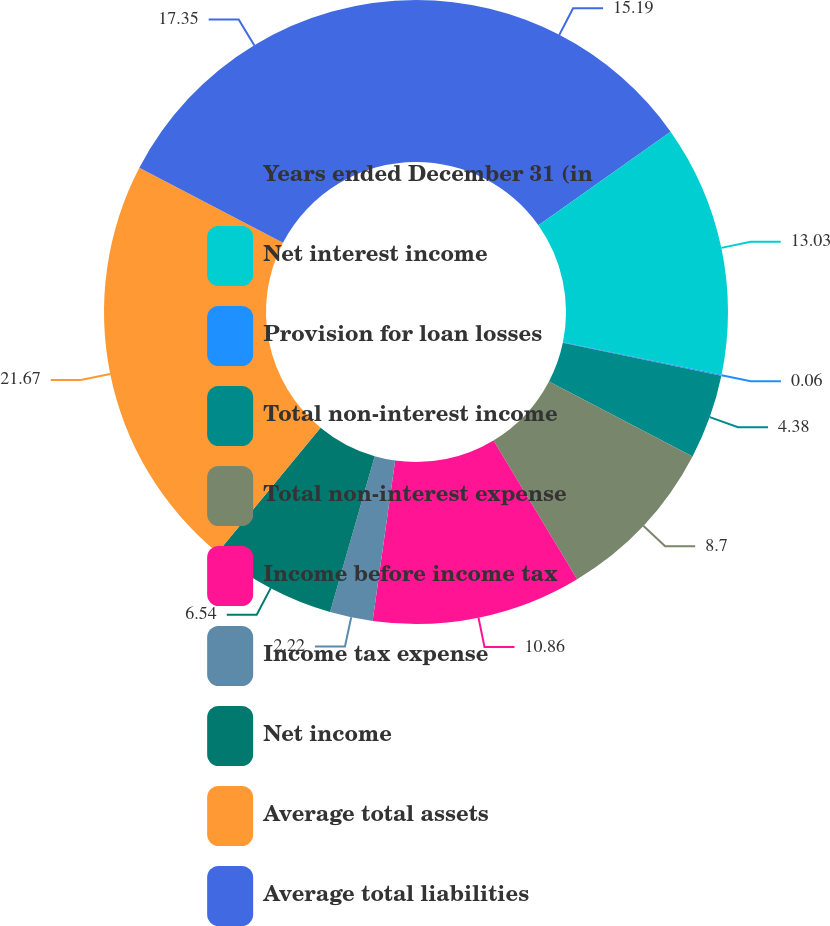Convert chart. <chart><loc_0><loc_0><loc_500><loc_500><pie_chart><fcel>Years ended December 31 (in<fcel>Net interest income<fcel>Provision for loan losses<fcel>Total non-interest income<fcel>Total non-interest expense<fcel>Income before income tax<fcel>Income tax expense<fcel>Net income<fcel>Average total assets<fcel>Average total liabilities<nl><fcel>15.19%<fcel>13.03%<fcel>0.06%<fcel>4.38%<fcel>8.7%<fcel>10.86%<fcel>2.22%<fcel>6.54%<fcel>21.67%<fcel>17.35%<nl></chart> 